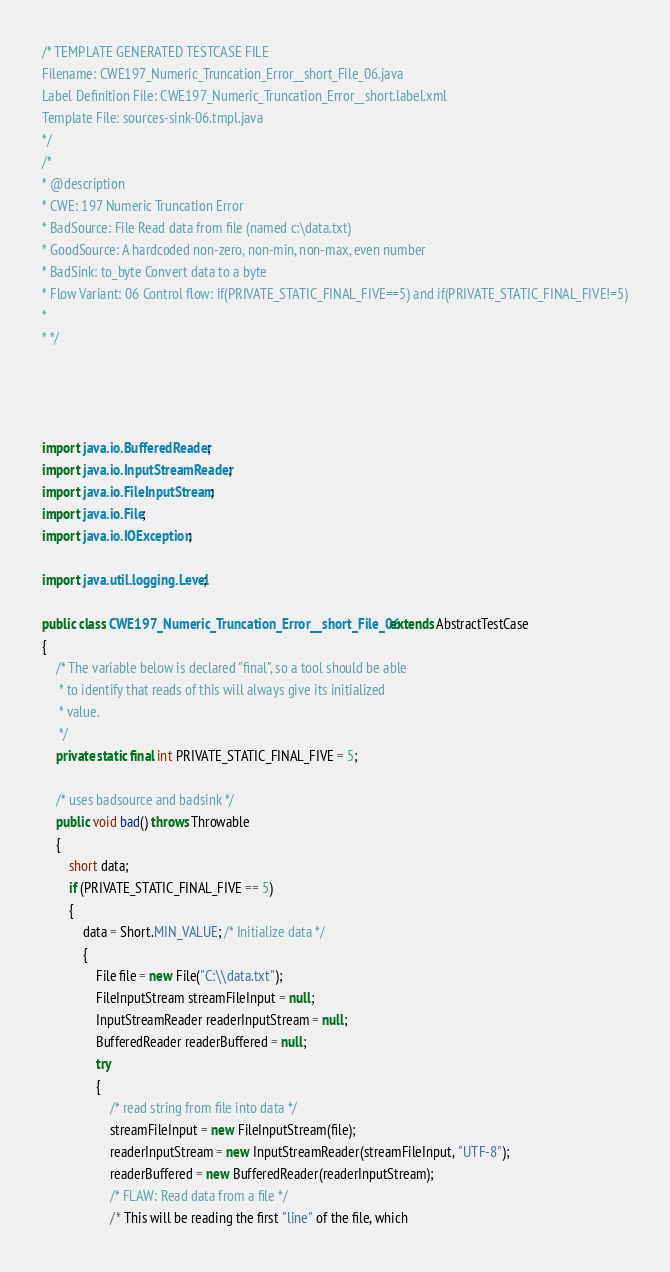<code> <loc_0><loc_0><loc_500><loc_500><_Java_>/* TEMPLATE GENERATED TESTCASE FILE
Filename: CWE197_Numeric_Truncation_Error__short_File_06.java
Label Definition File: CWE197_Numeric_Truncation_Error__short.label.xml
Template File: sources-sink-06.tmpl.java
*/
/*
* @description
* CWE: 197 Numeric Truncation Error
* BadSource: File Read data from file (named c:\data.txt)
* GoodSource: A hardcoded non-zero, non-min, non-max, even number
* BadSink: to_byte Convert data to a byte
* Flow Variant: 06 Control flow: if(PRIVATE_STATIC_FINAL_FIVE==5) and if(PRIVATE_STATIC_FINAL_FIVE!=5)
*
* */




import java.io.BufferedReader;
import java.io.InputStreamReader;
import java.io.FileInputStream;
import java.io.File;
import java.io.IOException;

import java.util.logging.Level;

public class CWE197_Numeric_Truncation_Error__short_File_06 extends AbstractTestCase
{
    /* The variable below is declared "final", so a tool should be able
     * to identify that reads of this will always give its initialized
     * value.
     */
    private static final int PRIVATE_STATIC_FINAL_FIVE = 5;

    /* uses badsource and badsink */
    public void bad() throws Throwable
    {
        short data;
        if (PRIVATE_STATIC_FINAL_FIVE == 5)
        {
            data = Short.MIN_VALUE; /* Initialize data */
            {
                File file = new File("C:\\data.txt");
                FileInputStream streamFileInput = null;
                InputStreamReader readerInputStream = null;
                BufferedReader readerBuffered = null;
                try
                {
                    /* read string from file into data */
                    streamFileInput = new FileInputStream(file);
                    readerInputStream = new InputStreamReader(streamFileInput, "UTF-8");
                    readerBuffered = new BufferedReader(readerInputStream);
                    /* FLAW: Read data from a file */
                    /* This will be reading the first "line" of the file, which</code> 